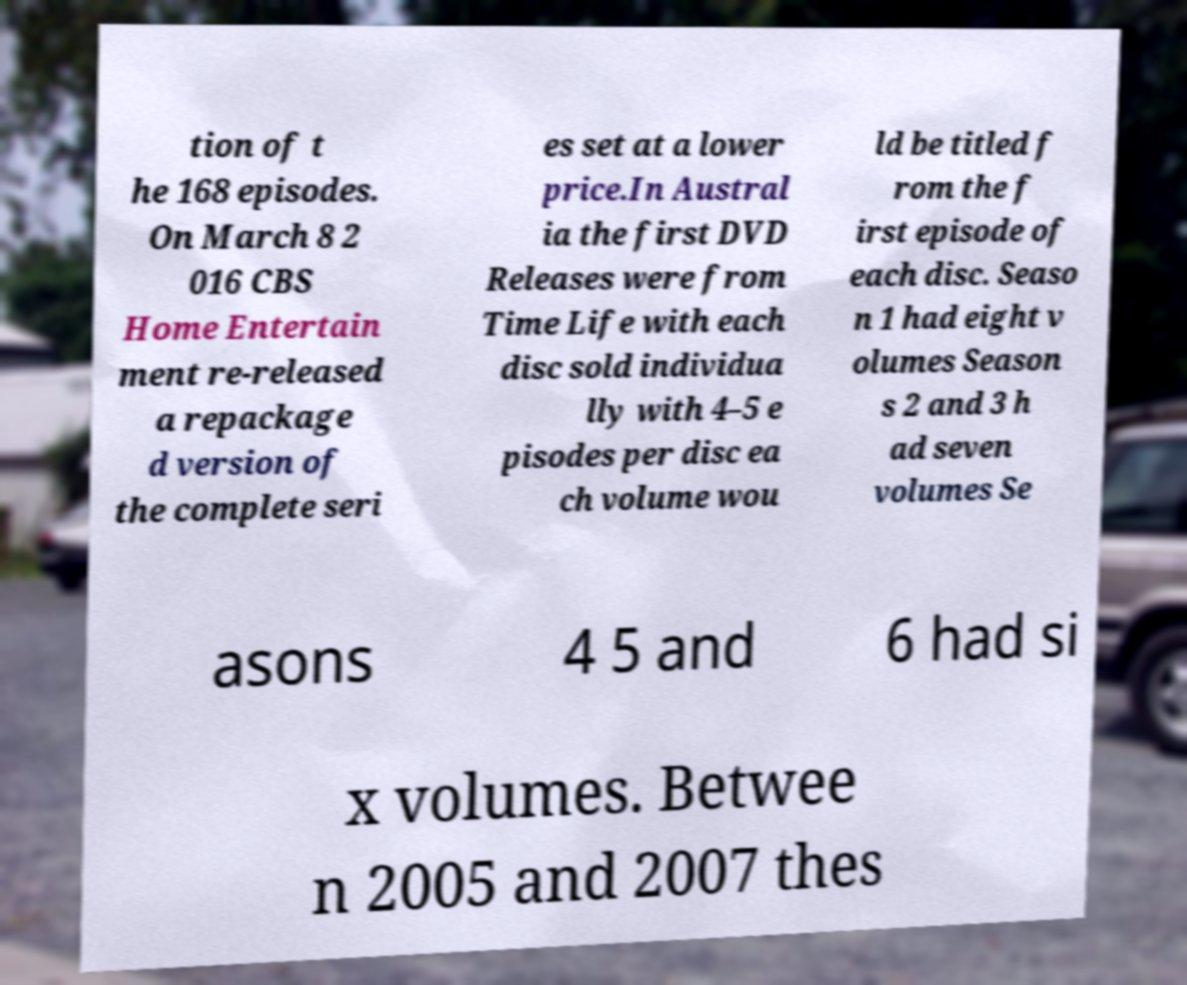Can you read and provide the text displayed in the image?This photo seems to have some interesting text. Can you extract and type it out for me? tion of t he 168 episodes. On March 8 2 016 CBS Home Entertain ment re-released a repackage d version of the complete seri es set at a lower price.In Austral ia the first DVD Releases were from Time Life with each disc sold individua lly with 4–5 e pisodes per disc ea ch volume wou ld be titled f rom the f irst episode of each disc. Seaso n 1 had eight v olumes Season s 2 and 3 h ad seven volumes Se asons 4 5 and 6 had si x volumes. Betwee n 2005 and 2007 thes 